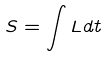<formula> <loc_0><loc_0><loc_500><loc_500>S = \int L d t</formula> 